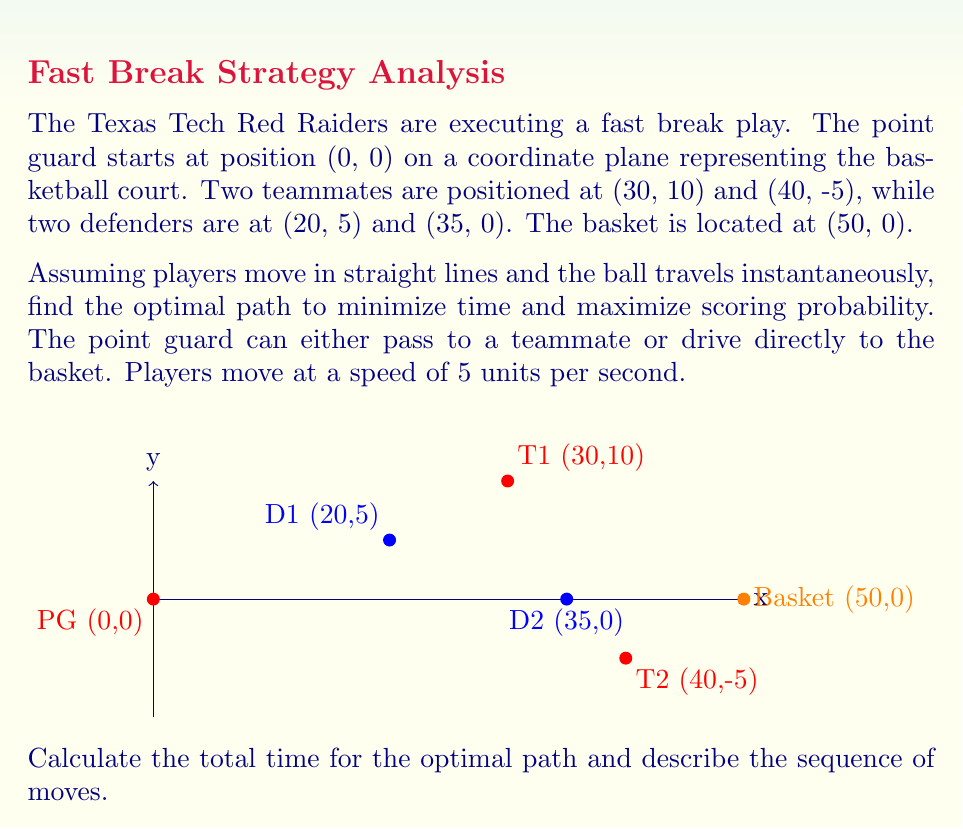Can you answer this question? Let's approach this step-by-step:

1) First, we need to calculate the distances for all possible paths:

   a) PG to Basket: $\sqrt{50^2 + 0^2} = 50$ units
   b) PG to T1: $\sqrt{30^2 + 10^2} = \sqrt{1000} \approx 31.62$ units
   c) PG to T2: $\sqrt{40^2 + (-5)^2} = \sqrt{1625} \approx 40.31$ units
   d) T1 to Basket: $\sqrt{20^2 + (-10)^2} = \sqrt{500} \approx 22.36$ units
   e) T2 to Basket: $\sqrt{10^2 + 5^2} = \sqrt{125} \approx 11.18$ units

2) Now, let's calculate the time for each possible path:

   a) PG directly to Basket: $50/5 = 10$ seconds
   b) PG to T1 to Basket: $(31.62 + 22.36)/5 \approx 10.80$ seconds
   c) PG to T2 to Basket: $(40.31 + 11.18)/5 \approx 10.30$ seconds

3) The fastest path is the direct route from PG to Basket at 10 seconds.

4) However, we also need to consider the defenders:
   - D1 is closer to T1, potentially intercepting a pass to T1.
   - D2 is in a good position to intercept a direct drive by PG.

5) Considering both time and scoring probability:
   - The pass to T2 avoids both defenders and gives a clear path to the basket.
   - While slightly slower than the direct route, it maximizes scoring probability.

6) The optimal path is: PG passes to T2, then T2 drives to the basket.
   Total time: $(40.31 + 11.18)/5 \approx 10.30$ seconds
Answer: PG passes to T2, T2 drives to basket. Time: 10.30 seconds. 